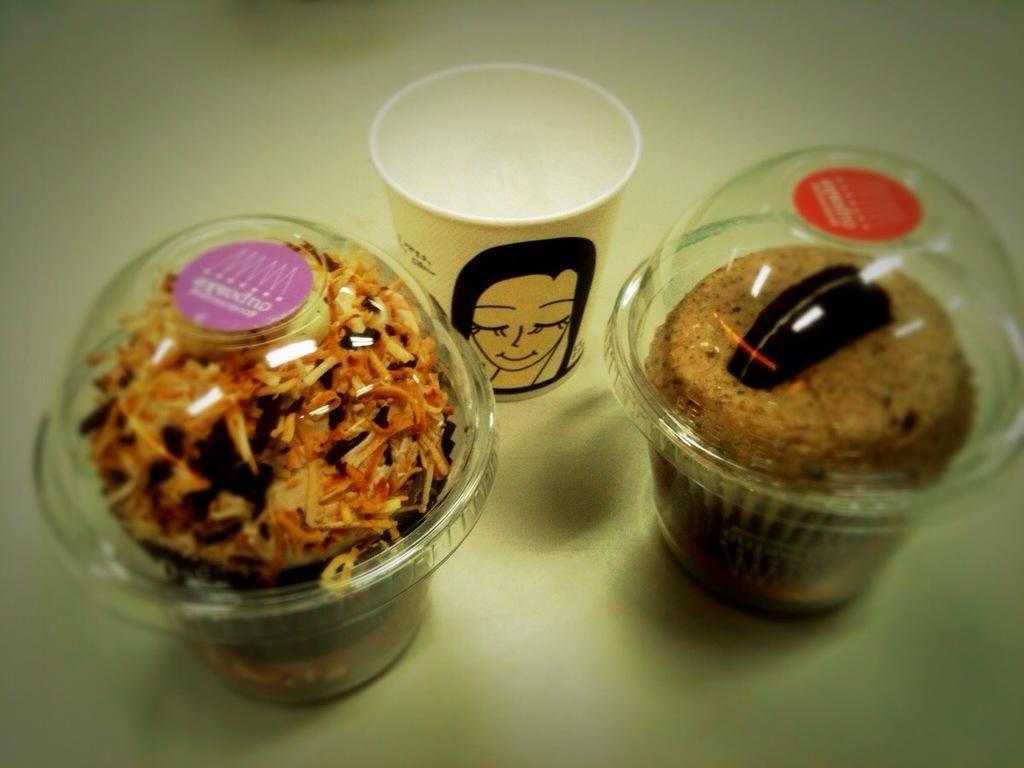Describe this image in one or two sentences. In this image we can see food items in the plastic container and there are placed on a white surface. There is a white glass with a label. On the label we can see some text and image. 